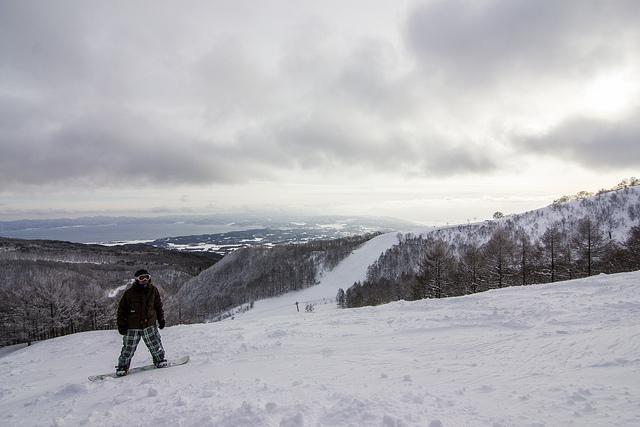How many large elephants are standing?
Give a very brief answer. 0. 